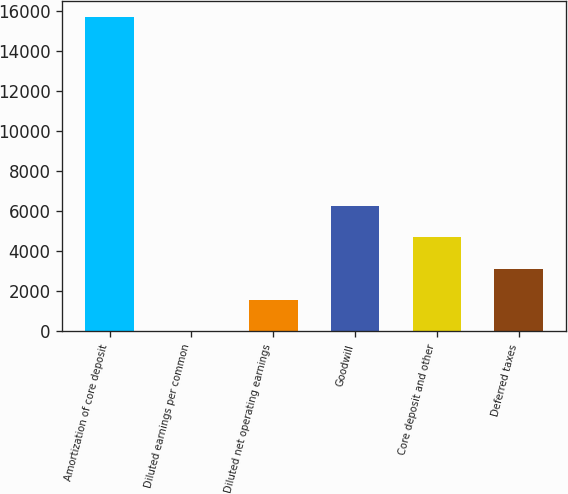Convert chart to OTSL. <chart><loc_0><loc_0><loc_500><loc_500><bar_chart><fcel>Amortization of core deposit<fcel>Diluted earnings per common<fcel>Diluted net operating earnings<fcel>Goodwill<fcel>Core deposit and other<fcel>Deferred taxes<nl><fcel>15702<fcel>1.83<fcel>1571.85<fcel>6281.91<fcel>4711.89<fcel>3141.87<nl></chart> 